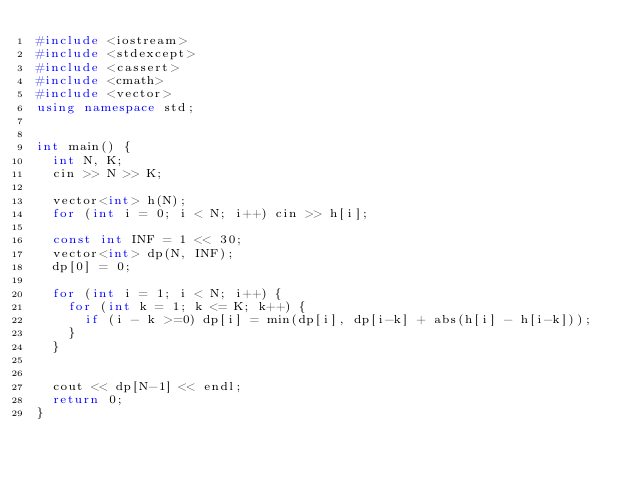<code> <loc_0><loc_0><loc_500><loc_500><_C++_>#include <iostream>
#include <stdexcept>
#include <cassert>
#include <cmath>
#include <vector>
using namespace std;


int main() {
  int N, K;
  cin >> N >> K;

  vector<int> h(N);
  for (int i = 0; i < N; i++) cin >> h[i];

  const int INF = 1 << 30;
  vector<int> dp(N, INF);
  dp[0] = 0;

  for (int i = 1; i < N; i++) {
    for (int k = 1; k <= K; k++) {
      if (i - k >=0) dp[i] = min(dp[i], dp[i-k] + abs(h[i] - h[i-k]));
    }
  }


  cout << dp[N-1] << endl;
  return 0;
}
</code> 